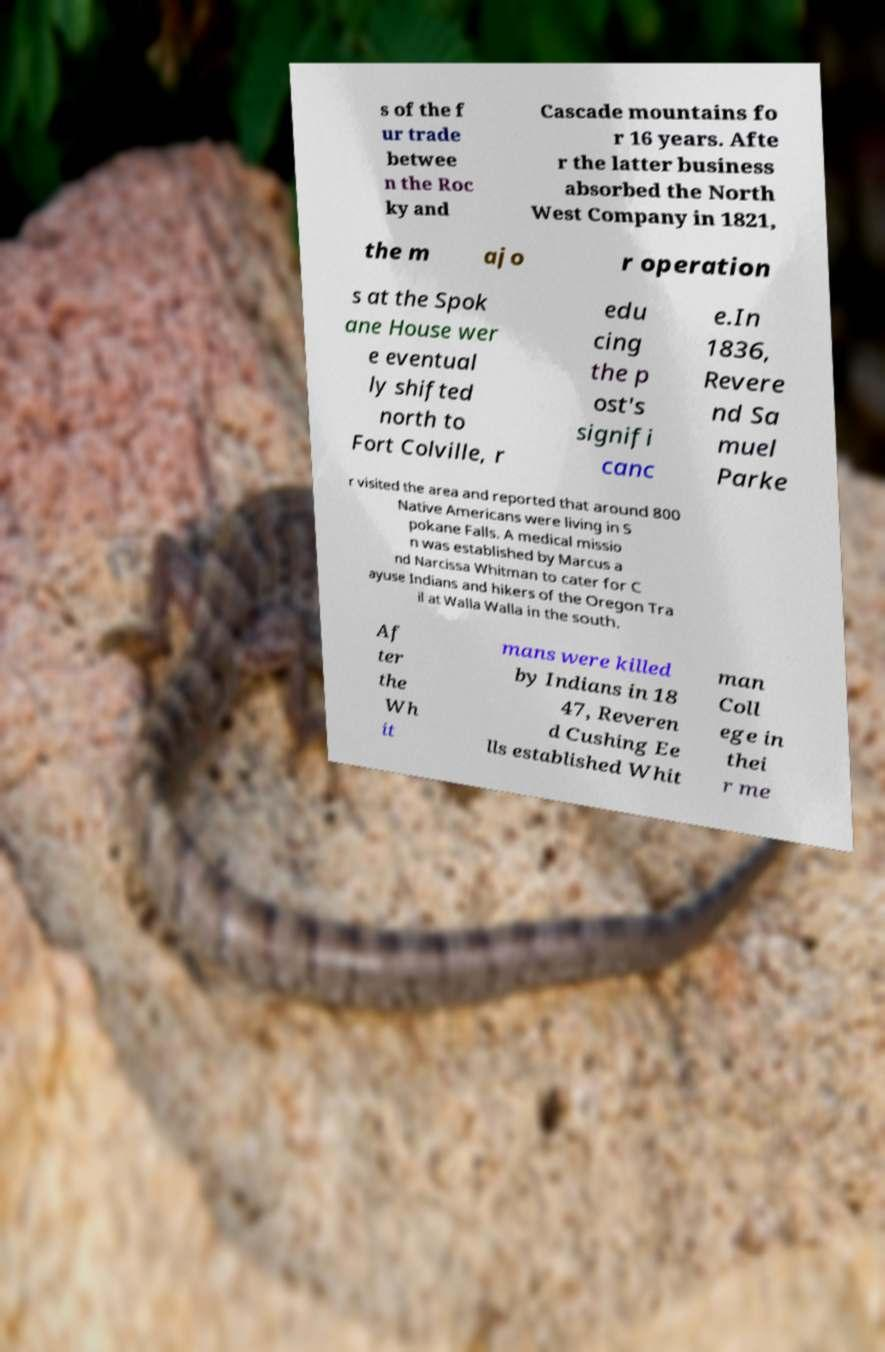Please read and relay the text visible in this image. What does it say? s of the f ur trade betwee n the Roc ky and Cascade mountains fo r 16 years. Afte r the latter business absorbed the North West Company in 1821, the m ajo r operation s at the Spok ane House wer e eventual ly shifted north to Fort Colville, r edu cing the p ost's signifi canc e.In 1836, Revere nd Sa muel Parke r visited the area and reported that around 800 Native Americans were living in S pokane Falls. A medical missio n was established by Marcus a nd Narcissa Whitman to cater for C ayuse Indians and hikers of the Oregon Tra il at Walla Walla in the south. Af ter the Wh it mans were killed by Indians in 18 47, Reveren d Cushing Ee lls established Whit man Coll ege in thei r me 